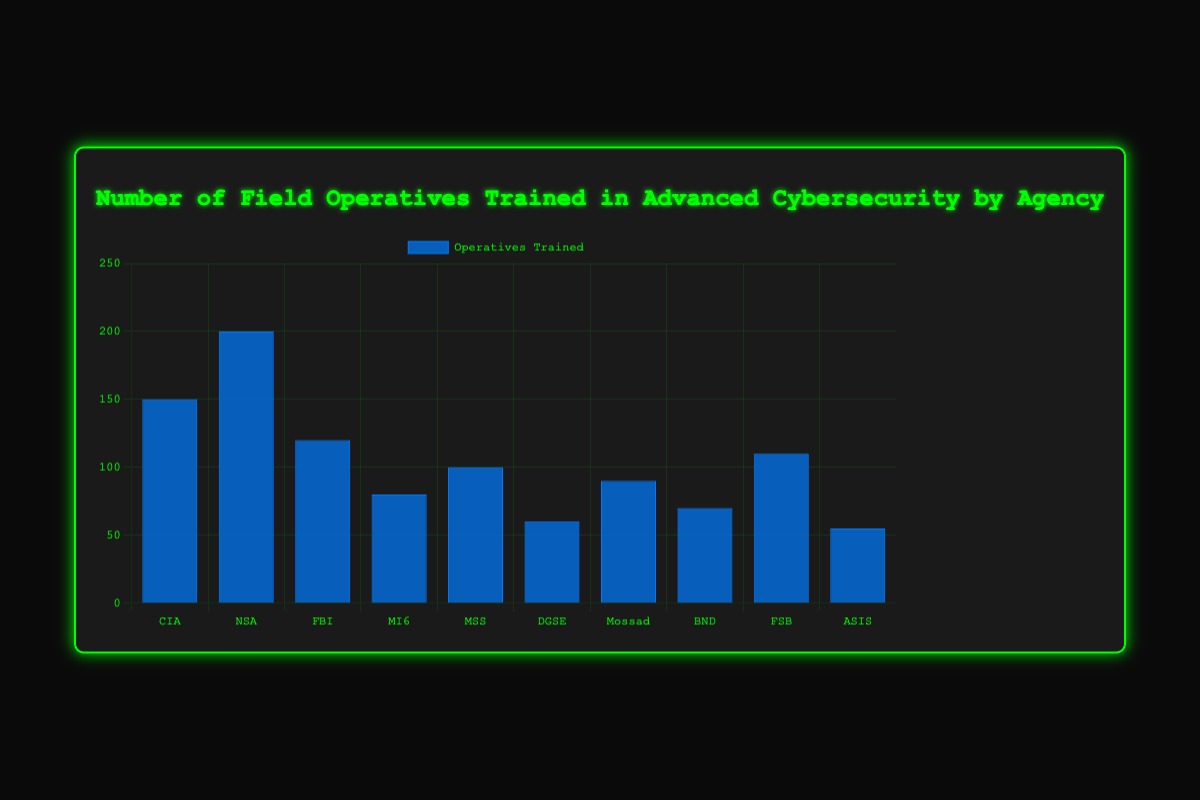Which agency trained the highest number of operatives? The bar for NSA is the tallest, indicating it trained the highest number of operatives.
Answer: NSA Which agency trained the least number of operatives? The bar for ASIS is the shortest, indicating it trained the least number of operatives.
Answer: ASIS How many more operatives did the NSA train compared to the CIA? NSA trained 200 operatives and CIA trained 150. Subtract 150 from 200 to find the difference.
Answer: 50 What is the total number of operatives trained by CIA, FBI, and MI6 combined? Add 150 (CIA) + 120 (FBI) + 80 (MI6).
Answer: 350 How does the number of operatives trained by FBI compare to those trained by MSS? Compare the heights of the bars corresponding to FBI and MSS. FBI trained 120 operatives, and MSS trained 100 operatives. FBI trained more.
Answer: FBI Which agency trained fewer operatives than the FBI but more than the DGSE? Look at the agencies with operatives trained between 60 and 120. MSS trained 100, which fits this range.
Answer: MSS Calculate the average number of operatives trained by all agencies. Sum the operatives trained by all agencies: 150 + 200 + 120 + 80 + 100 + 60 + 90 + 70 + 110 + 55 = 1035. Divide by the number of agencies, which is 10.
Answer: 103.5 Are there more agencies with fewer than 100 operatives trained or with 100 or more operatives trained? Count the agencies with fewer than 100 (DGSE, Mossad, BND, ASIS, MI6) and those with 100 or more (CIA, NSA, FBI, MSS, FSB). Both categories have 5 agencies each.
Answer: Equal What is the difference between the number of operatives trained by the top two agencies and the bottom two agencies? Top two: NSA (200) + CIA (150) = 350. Bottom two: DGSE (60) + ASIS (55) = 115. Subtract 115 from 350.
Answer: 235 